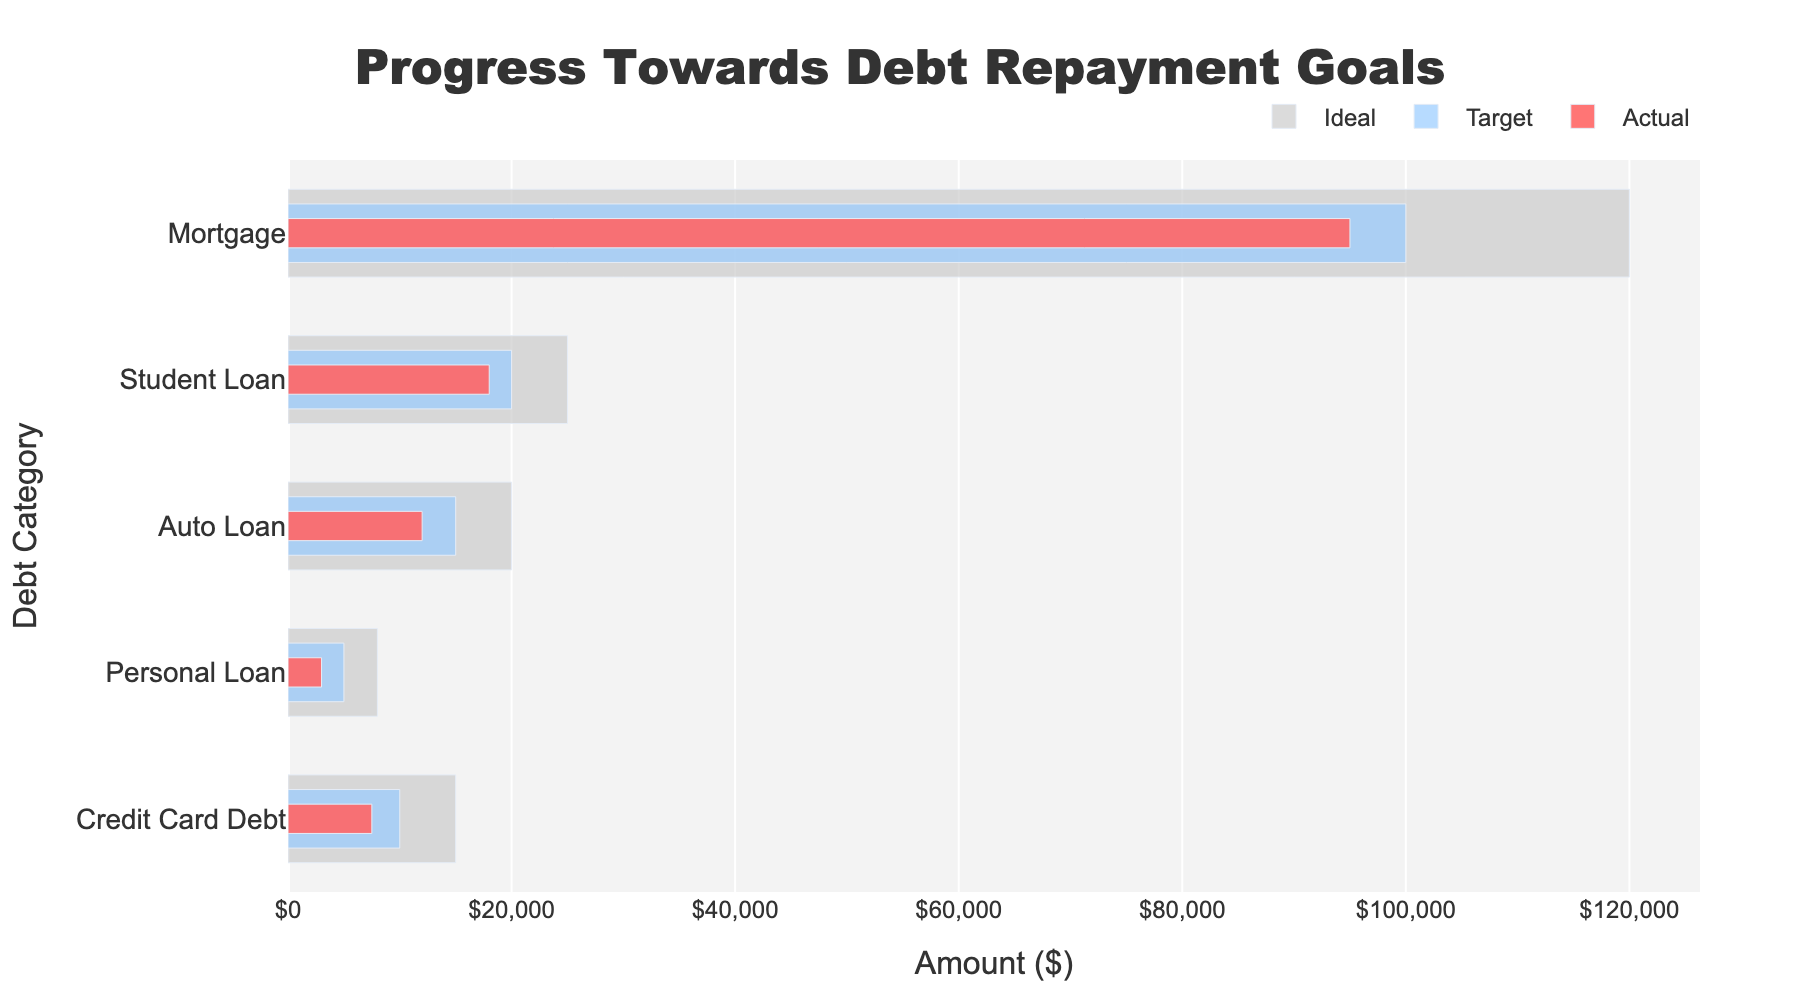What's the title of the chart? The title of the chart is usually displayed at the top of the figure. It is clearly labeled and states the purpose of the chart.
Answer: Progress Towards Debt Repayment Goals What is the x-axis representing? The x-axis generally represents the variable that is measured horizontally across the chart. In this case, it is labeled "Amount ($)," indicating it is measuring financial amounts in dollars.
Answer: Amount ($) How many debt categories are displayed? The number of data points or categories is found on the y-axis, which lists out each debt type. Counting these gives us the total number.
Answer: 5 What color represents 'Actual' debt values? The colors of the bars are indicated by different hues. The 'Actual' debt values are represented by the red bars.
Answer: Red Which debt category has the highest actual debt value? By comparing the lengths of the red bars, the longest bar indicates the highest actual debt value. The 'Mortgage' category has the longest red bar.
Answer: Mortgage Which debt category is closest to its target repayment goal? To determine this, compare the lengths of the red bars (Actual) to the blue bars (Target). The category where the red and blue bars are closest in length is the closest to the repayment goal.
Answer: Student Loan How much more does the 'Credit Card Debt' need to reach the target? Subtract the 'Actual' value from the 'Target' value for 'Credit Card Debt.' 10000 (Target) - 7500 (Actual) = 2500
Answer: 2500 What is the average ideal amount for all debt categories? Sum up all the ideal amounts: 15000 + 8000 + 20000 + 25000 + 120000 = 188000. The average is then calculated by dividing by the number of categories, 188000 / 5.
Answer: 37600 Which debt category has the largest difference between the ideal and target values? For each category, subtract the target from the ideal value. Identify the category with the highest difference.
- Credit Card Debt: 15000 - 10000 = 5000
- Personal Loan: 8000 - 5000 = 3000
- Auto Loan: 20000 - 15000 = 5000
- Student Loan: 25000 - 20000 = 5000
- Mortgage: 120000 - 100000 = 20000
The Mortgage category has the highest difference.
Answer: Mortgage 